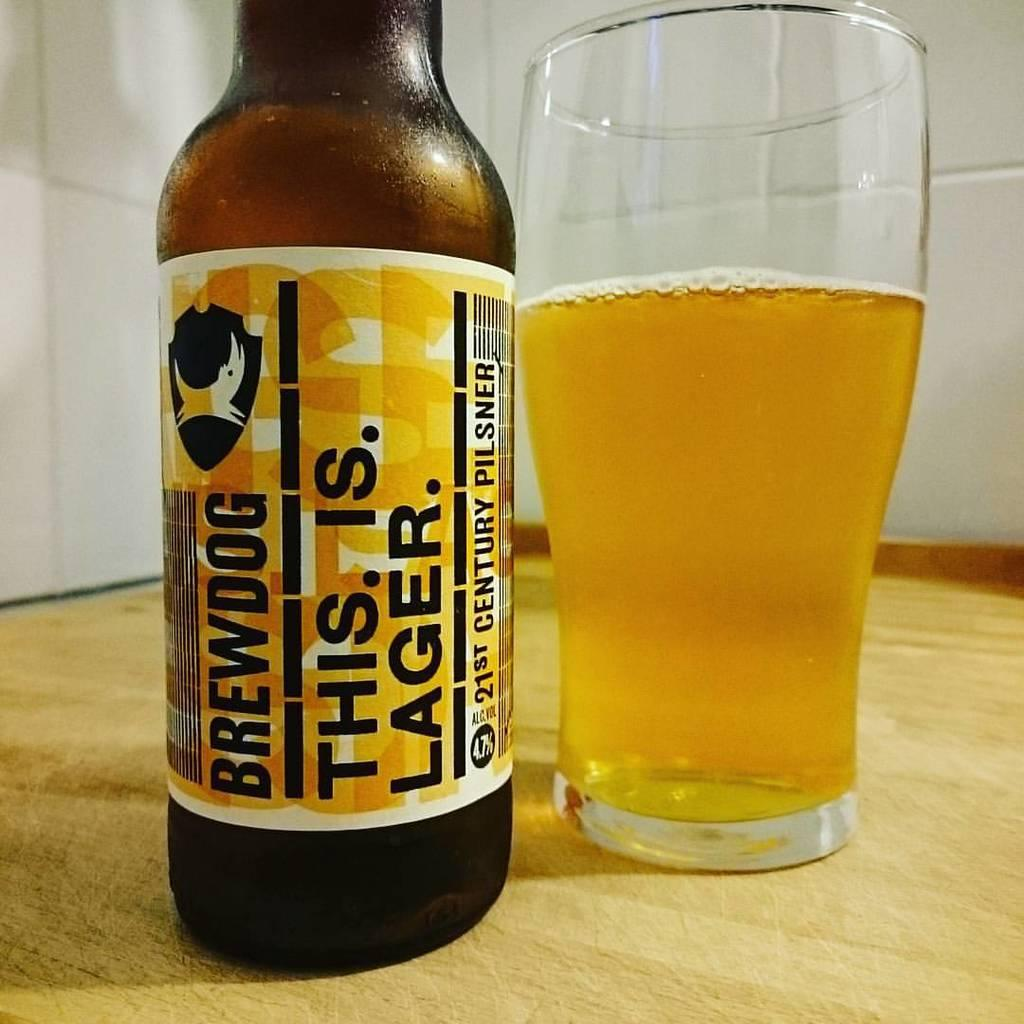<image>
Relay a brief, clear account of the picture shown. A half-full glass of beer sits next to a bottle of Brewdog lager. 